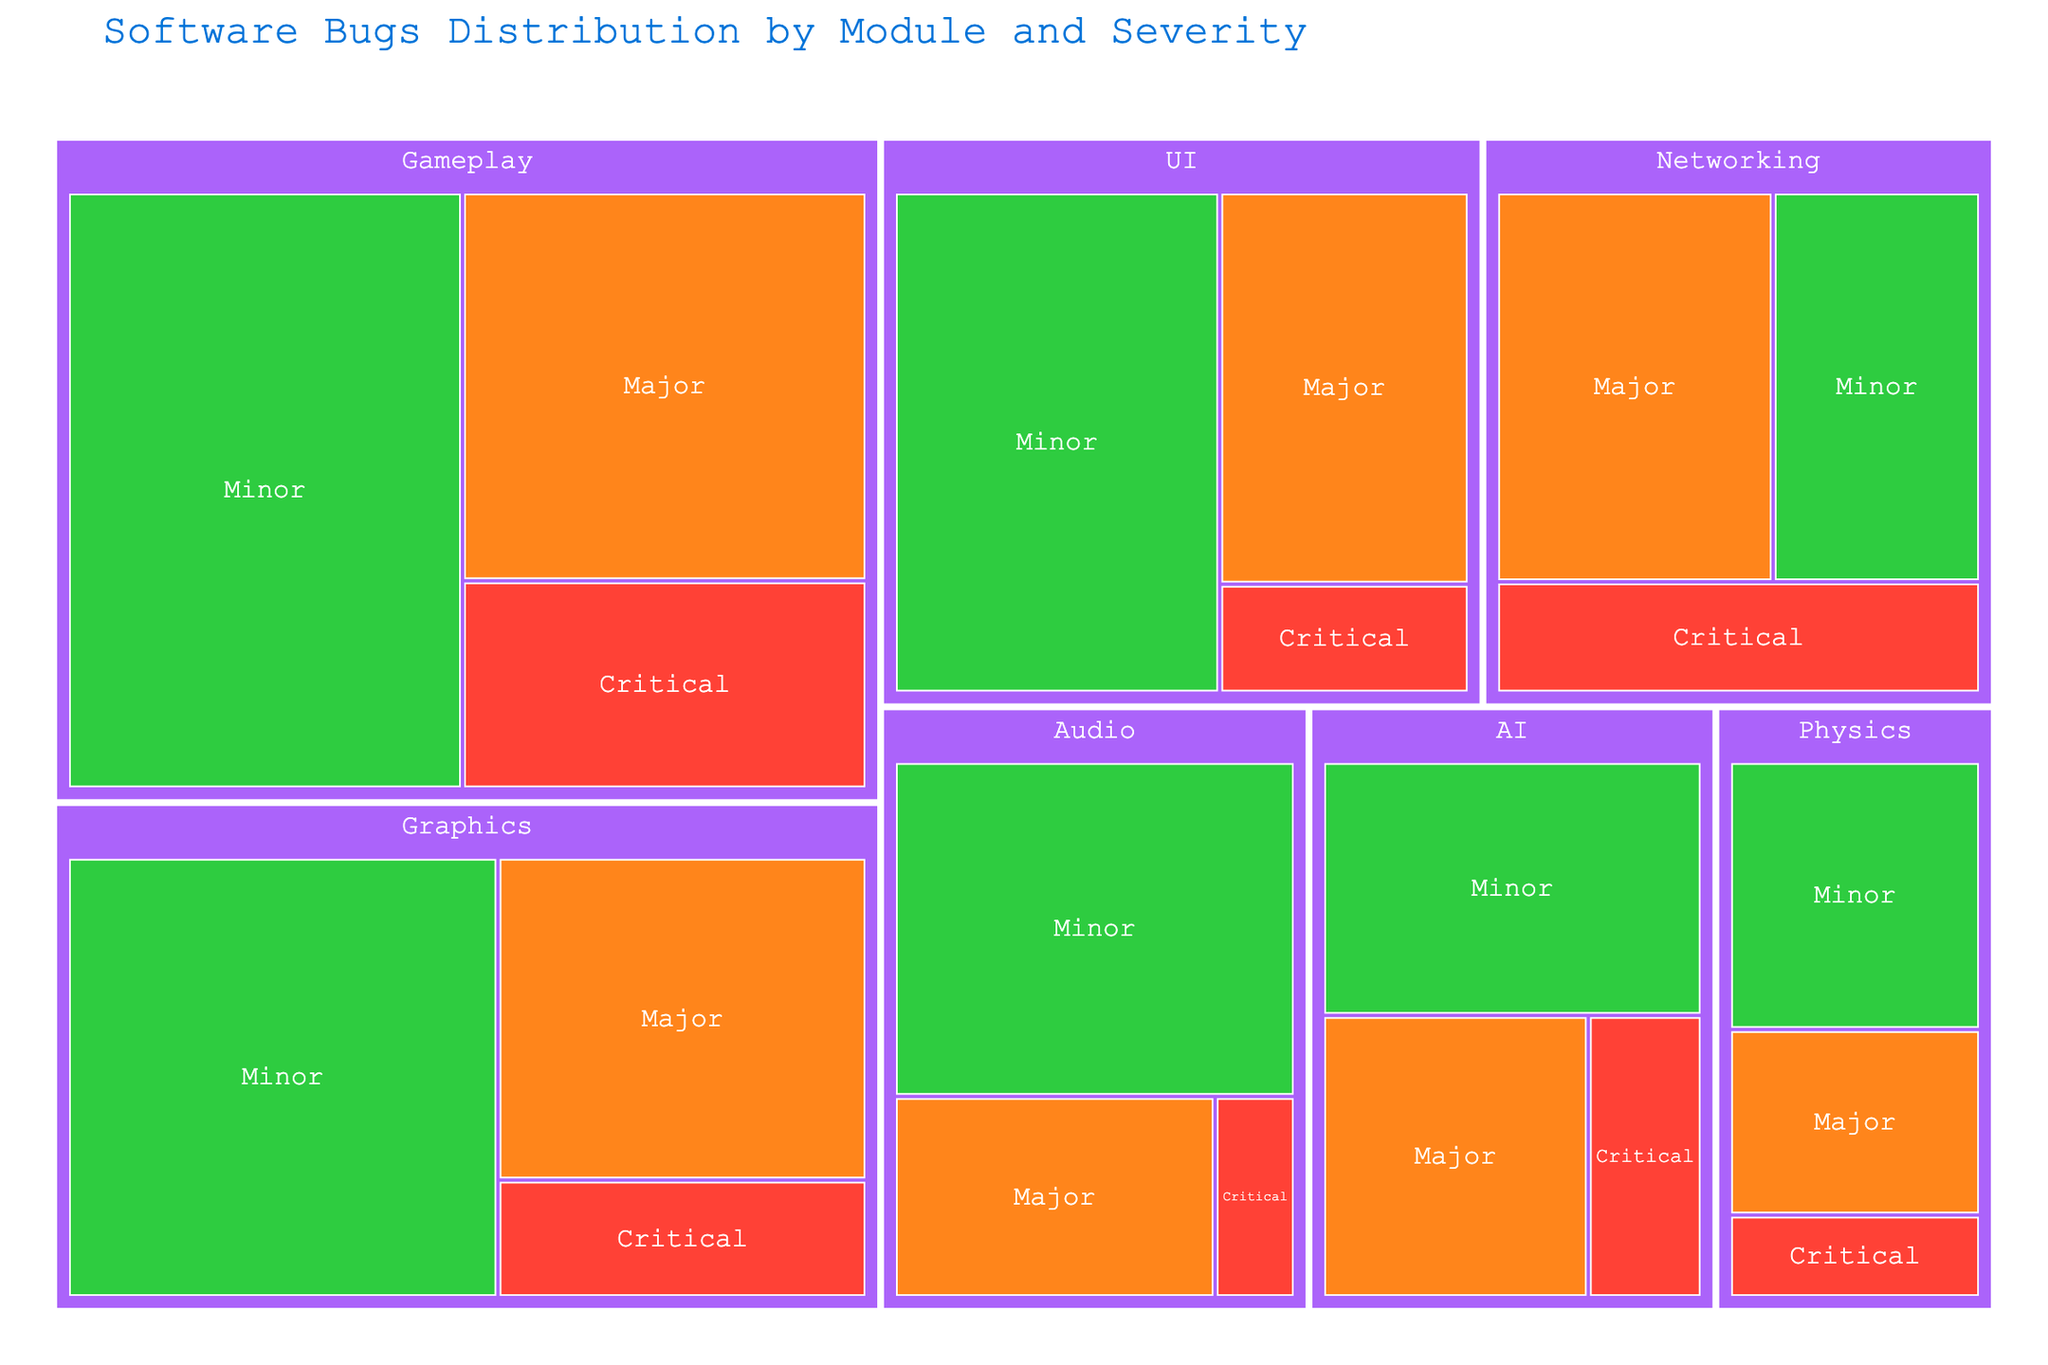What's the total number of Critical bugs? To find the total number of Critical bugs, sum up the counts of Critical bugs from all the modules: 15 (Gameplay) + 8 (Graphics) + 5 (UI) + 3 (Audio) + 10 (Networking) + 6 (AI) + 4 (Physics) = 51
Answer: 51 What's the module with the highest number of Major bugs? To determine the module with the highest number of Major bugs, compare the counts of Major bugs in each module: 28 (Gameplay), 22 (Graphics), 18 (UI), 12 (Audio), 20 (Networking), 14 (AI), 9 (Physics). Gameplay has the highest number with 28.
Answer: Gameplay Which module has the fewest Critical bugs? Observe the counts of Critical bugs across all modules: 15 (Gameplay), 8 (Graphics), 5 (UI), 3 (Audio), 10 (Networking), 6 (AI), 4 (Physics). Audio has the fewest with 3.
Answer: Audio How many bugs are there in total for the UI module? Sum up the counts of all severities for the UI module: 5 (Critical) + 18 (Major) + 30 (Minor) = 53
Answer: 53 What's the average number of Minor bugs per module? Sum up the counts of Minor bugs from all modules and divide by the number of modules: (42 + 35 + 30 + 25 + 15 + 18 + 13) / 7 = 178 / 7 ≈ 25.43
Answer: 25.43 Are there more Networking bugs or AI bugs overall? Compare the total counts of bugs in Networking and AI: Networking: 10 (Critical) + 20 (Major) + 15 (Minor) = 45, AI: 6 (Critical) + 14 (Major) + 18 (Minor) = 38. There are more bugs in Networking.
Answer: Networking How many more Major bugs are there in Graphics compared to Audio? Subtract the number of Major bugs in Audio from Graphics: 22 (Graphics) - 12 (Audio) = 10
Answer: 10 Which severity has the most number of bugs in total? Sum up the counts of each severity across all modules: Critical: 51, Major: 123, Minor: 178. Minor has the most with 178.
Answer: Minor What's the percentage of Minor bugs in the Physics module out of the total Physics bugs? Calculate the total bugs in Physics: 4 (Critical) + 9 (Major) + 13 (Minor) = 26. Then, (Minor / Total) * 100 = (13 / 26) * 100 ≈ 50%
Answer: 50% Identify the module with the least total number of bugs. Sum the total number of bugs for all modules and find the smallest: Gameplay: 85, Graphics: 65, UI: 53, Audio: 40, Networking: 45, AI: 38, Physics: 26. Physics has the least with 26.
Answer: Physics 